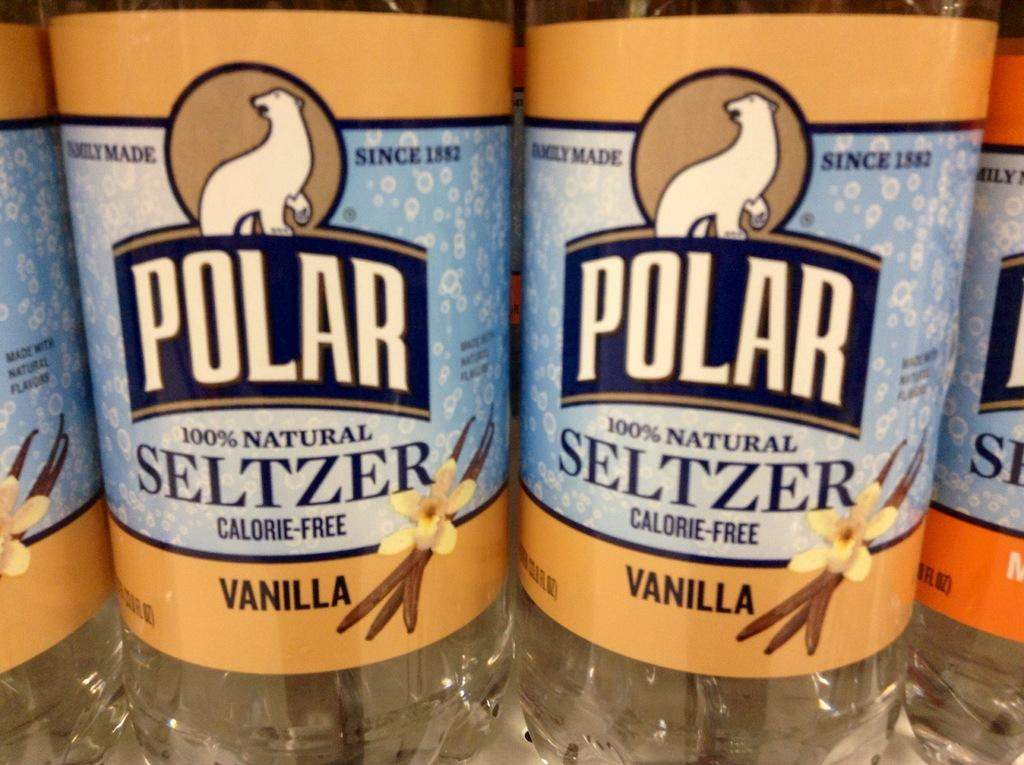<image>
Describe the image concisely. Close up of two bottles of Polar vanilla flavoured seltzer 